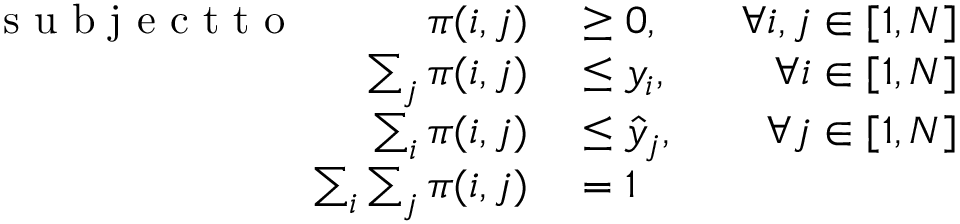Convert formula to latex. <formula><loc_0><loc_0><loc_500><loc_500>\begin{array} { r l r } { s u b j e c t t o \pi ( i , j ) } & \geq 0 , } & { \forall i , j \in [ 1 , N ] } \\ { \sum _ { j } \pi ( i , j ) } & \leq y _ { i } , } & { \forall i \in [ 1 , N ] } \\ { \sum _ { i } \pi ( i , j ) } & \leq \hat { y } _ { j } , } & { \forall j \in [ 1 , N ] } \\ { \sum _ { i } \sum _ { j } \pi ( i , j ) } & = 1 } \end{array}</formula> 